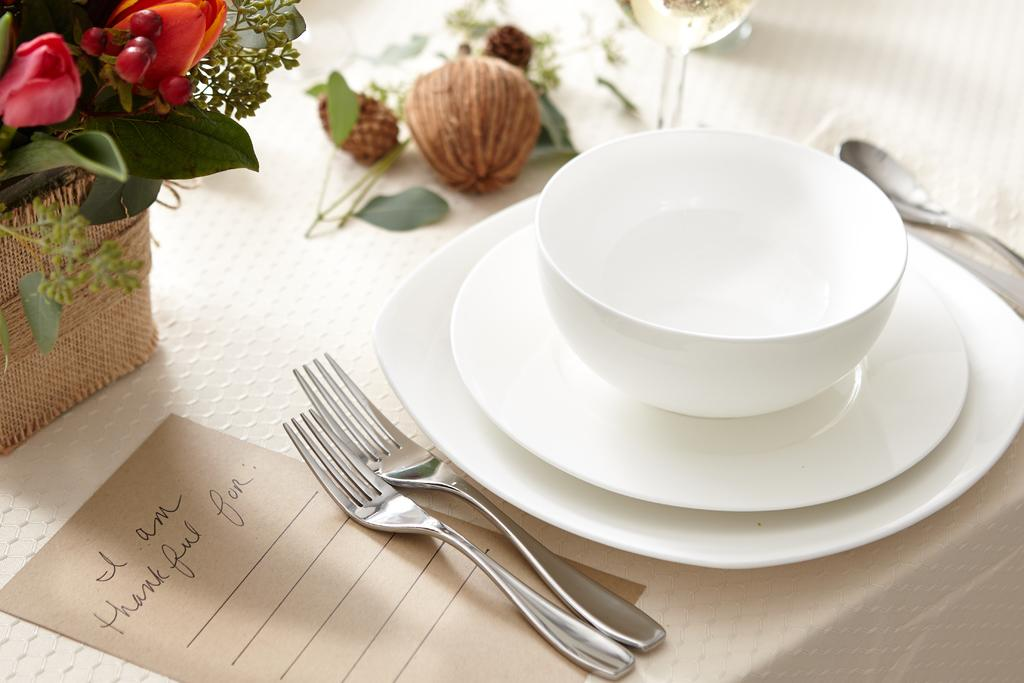What type of furniture is present in the image? There is a table in the image. What items can be seen on the table? There are crockery items, cutlery items, a postcard, flowers in a basket, and a glass tumbler on the table. What might be used for eating or drinking in the image? The crockery and cutlery items on the table can be used for eating or drinking. What type of decoration is present on the table? The flowers in a basket serve as decoration on the table. How does the rice balance on the table in the image? There is no rice present in the image, so it cannot be balanced on the table. 